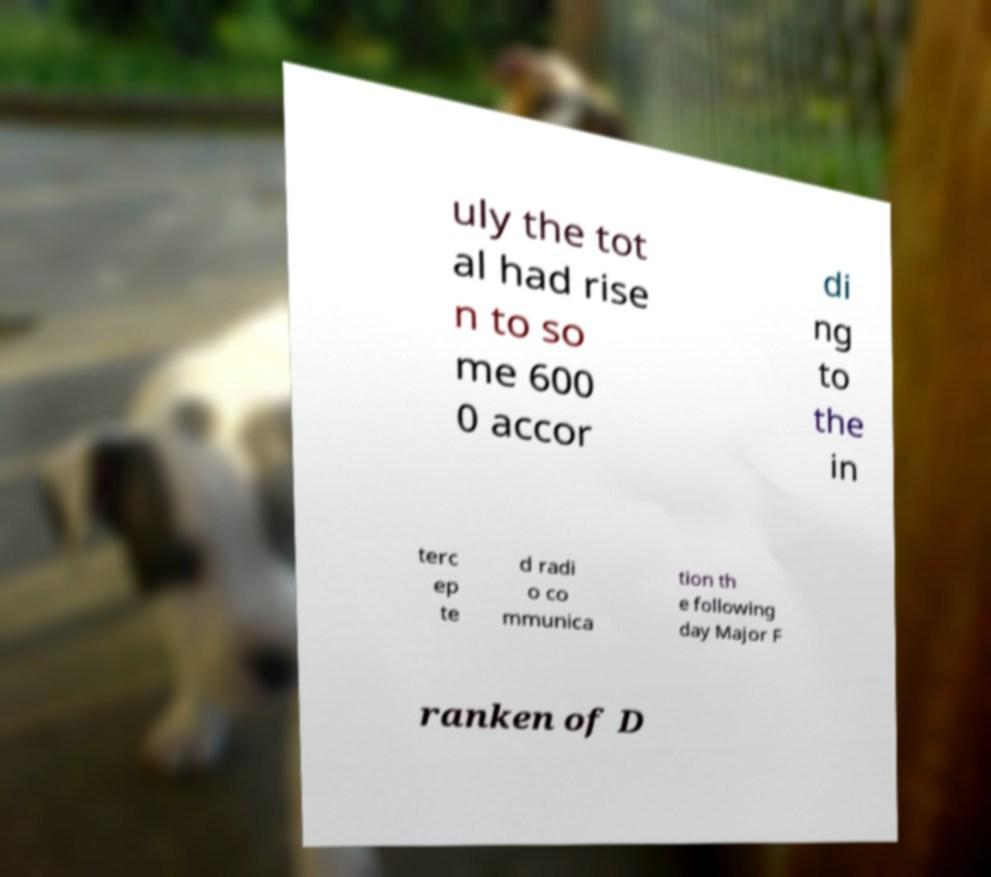What messages or text are displayed in this image? I need them in a readable, typed format. uly the tot al had rise n to so me 600 0 accor di ng to the in terc ep te d radi o co mmunica tion th e following day Major F ranken of D 